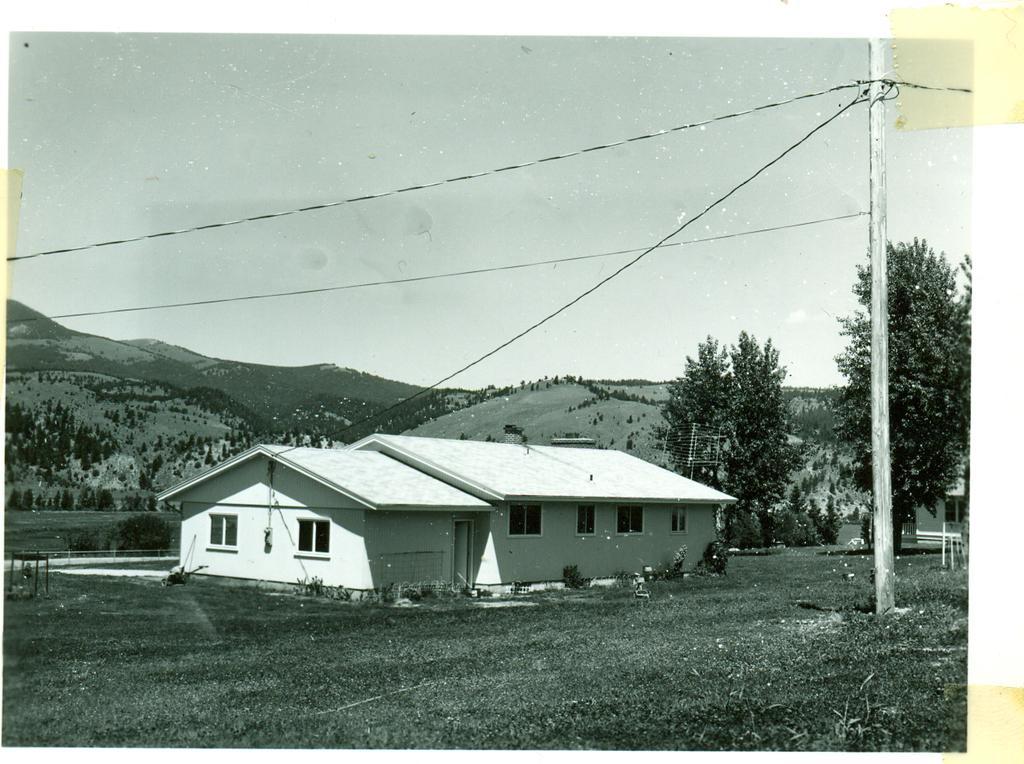Describe this image in one or two sentences. In this image in the center there is home. In the background there are trees. In the front there is a pole. On the ground there is grass and the sky is cloudy. 